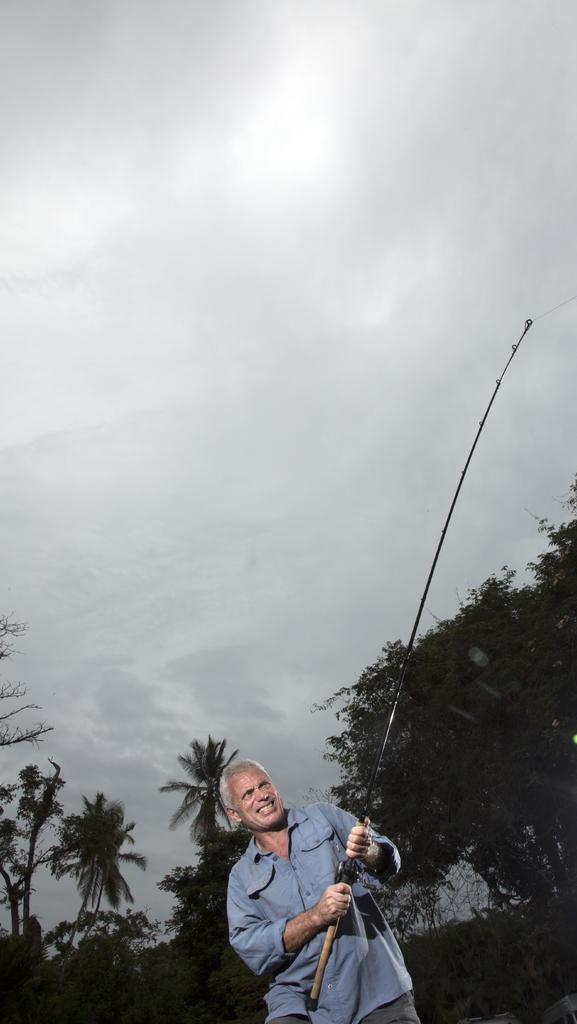What is the main subject of the image? There is a man standing in the image. What is the man wearing? The man is wearing clothes. What is the man holding in his hands? The man is holding a fishing rod in his hands. What type of natural environment can be seen in the image? There are trees visible in the image. What is the condition of the sky in the image? The sky is cloudy in the image. What type of rose can be seen on the user's bed in the image? There is no bed or rose present in the image; it features a man standing with a fishing rod. What is the user's tendency to engage in certain activities in the image? There is no information about the user's tendencies in the image, as it only shows the man standing with a fishing rod. 